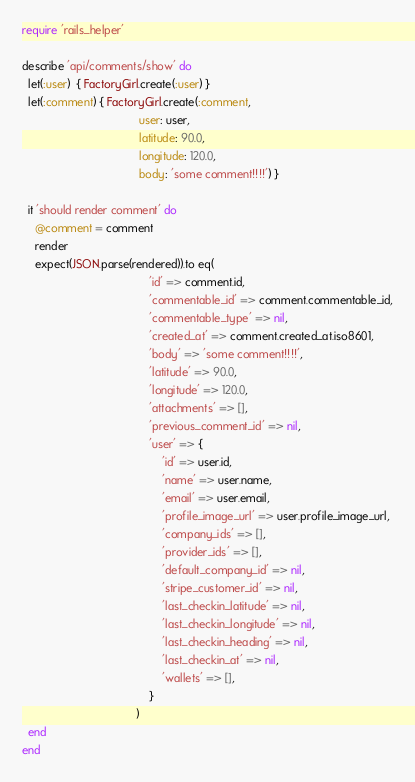Convert code to text. <code><loc_0><loc_0><loc_500><loc_500><_Ruby_>require 'rails_helper'

describe 'api/comments/show' do
  let(:user)  { FactoryGirl.create(:user) }
  let(:comment) { FactoryGirl.create(:comment,
                                     user: user,
                                     latitude: 90.0,
                                     longitude: 120.0,
                                     body: 'some comment!!!!') }

  it 'should render comment' do
    @comment = comment
    render
    expect(JSON.parse(rendered)).to eq(
                                        'id' => comment.id,
                                        'commentable_id' => comment.commentable_id,
                                        'commentable_type' => nil,
                                        'created_at' => comment.created_at.iso8601,
                                        'body' => 'some comment!!!!',
                                        'latitude' => 90.0,
                                        'longitude' => 120.0,
                                        'attachments' => [],
                                        'previous_comment_id' => nil,
                                        'user' => {
                                            'id' => user.id,
                                            'name' => user.name,
                                            'email' => user.email,
                                            'profile_image_url' => user.profile_image_url,
                                            'company_ids' => [],
                                            'provider_ids' => [],
                                            'default_company_id' => nil,
                                            'stripe_customer_id' => nil,
                                            'last_checkin_latitude' => nil,
                                            'last_checkin_longitude' => nil,
                                            'last_checkin_heading' => nil,
                                            'last_checkin_at' => nil,
                                            'wallets' => [],
                                        }
                                    )
  end
end
</code> 